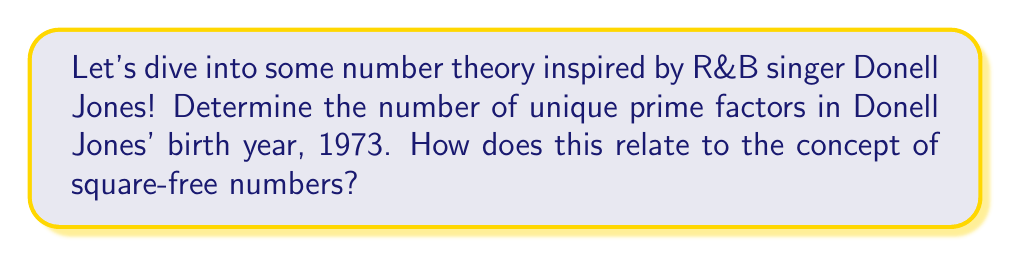Can you solve this math problem? Let's approach this step-by-step:

1) First, we need to find the prime factorization of 1973.

2) $1973 = 7 \times 23 \times 11$

3) This factorization shows that 1973 has three unique prime factors: 7, 23, and 11.

4) Now, let's consider how this relates to square-free numbers:

   - A square-free number is a number that is not divisible by any perfect square other than 1.
   - In the prime factorization of a square-free number, each prime factor appears only once.

5) Looking at the factorization of 1973, we can see that each prime factor (7, 23, and 11) appears only once.

6) Therefore, 1973 is indeed a square-free number.

7) In general, for any square-free number, the number of unique prime factors is equal to the total number of factors in its prime factorization.

This problem showcases how the birth year of an R&B artist we grew up listening to can be used to explore important concepts in number theory!
Answer: 3 unique prime factors; 1973 is square-free 